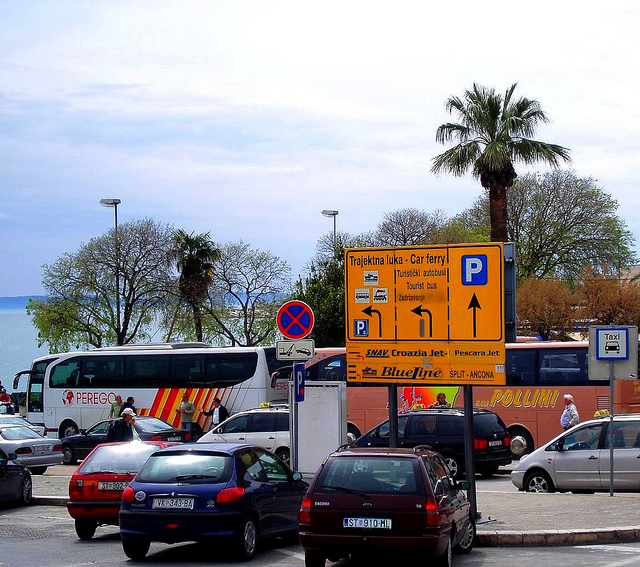Read all the text in this image. Trajektna luka Car ferry P BlueFine APLIT-ANCONA POLLINI Tax Set Pencarn Jet Croazia SNAK P Tourist ST 910 UK 343-84 ST 902 PEREGO 